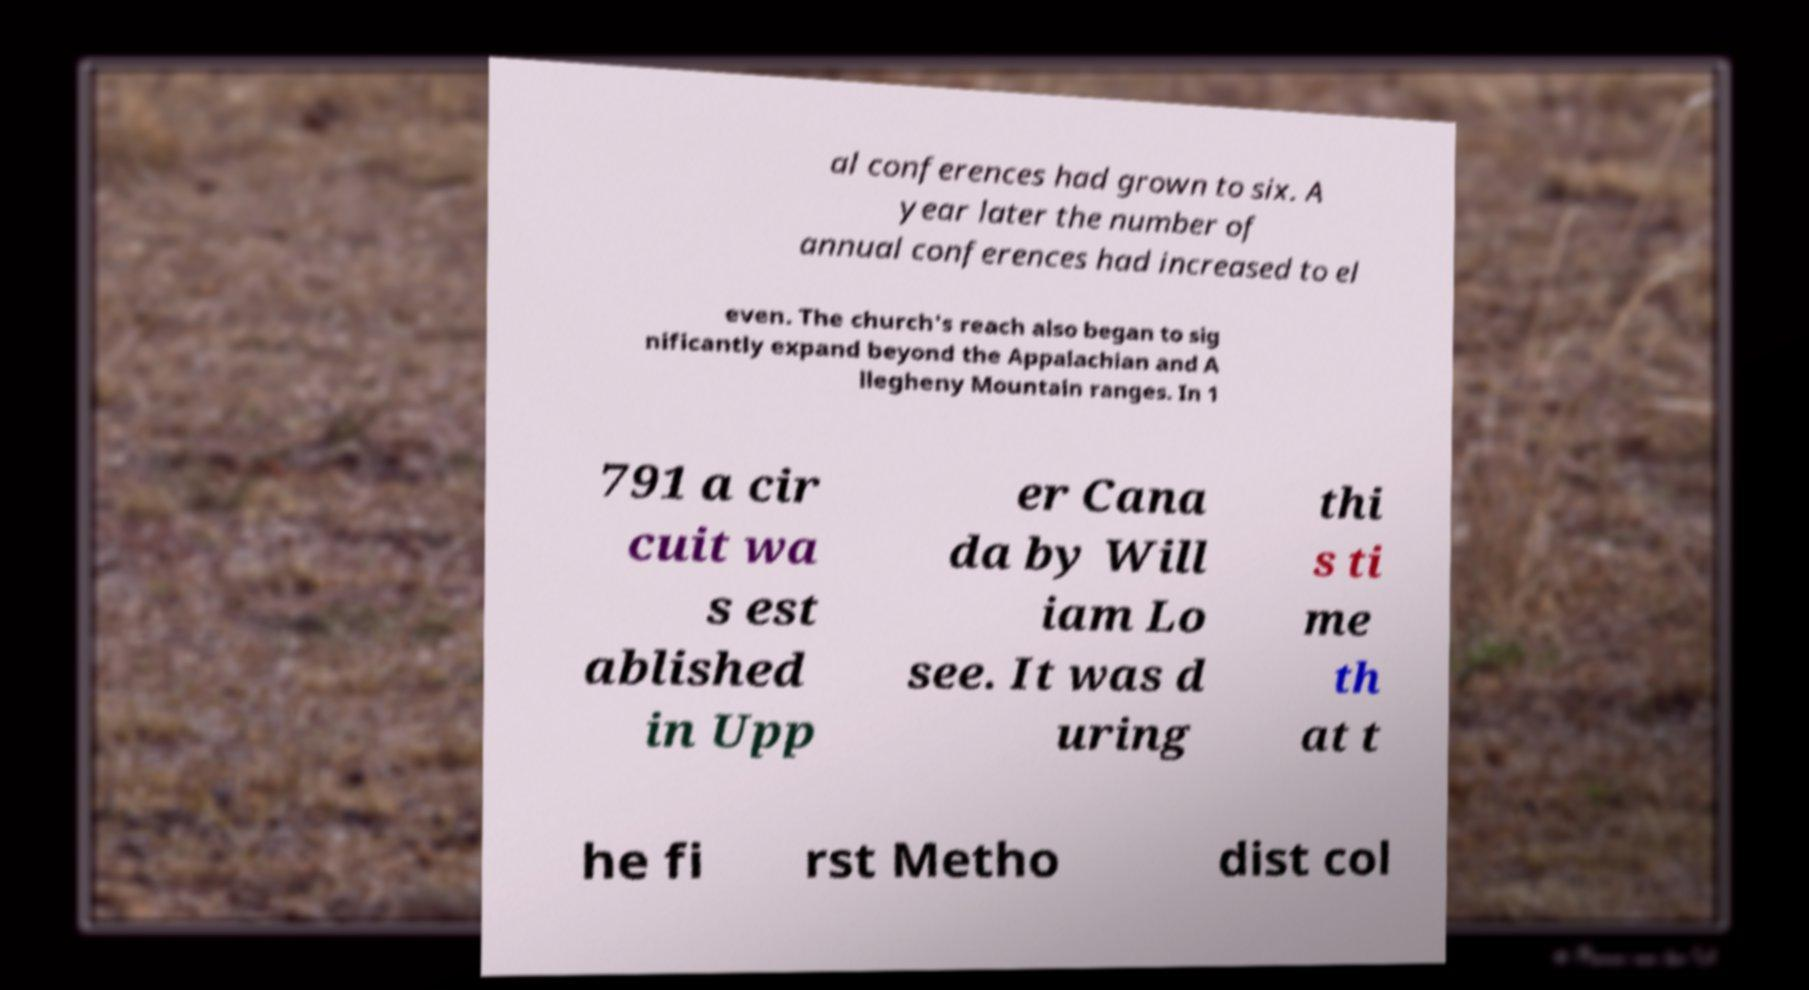Please read and relay the text visible in this image. What does it say? al conferences had grown to six. A year later the number of annual conferences had increased to el even. The church's reach also began to sig nificantly expand beyond the Appalachian and A llegheny Mountain ranges. In 1 791 a cir cuit wa s est ablished in Upp er Cana da by Will iam Lo see. It was d uring thi s ti me th at t he fi rst Metho dist col 